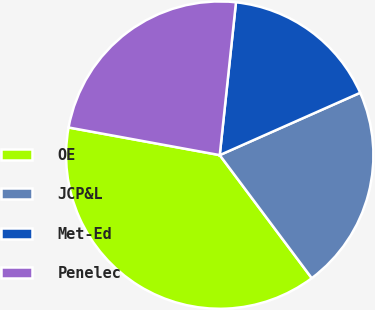<chart> <loc_0><loc_0><loc_500><loc_500><pie_chart><fcel>OE<fcel>JCP&L<fcel>Met-Ed<fcel>Penelec<nl><fcel>38.1%<fcel>21.43%<fcel>16.67%<fcel>23.81%<nl></chart> 